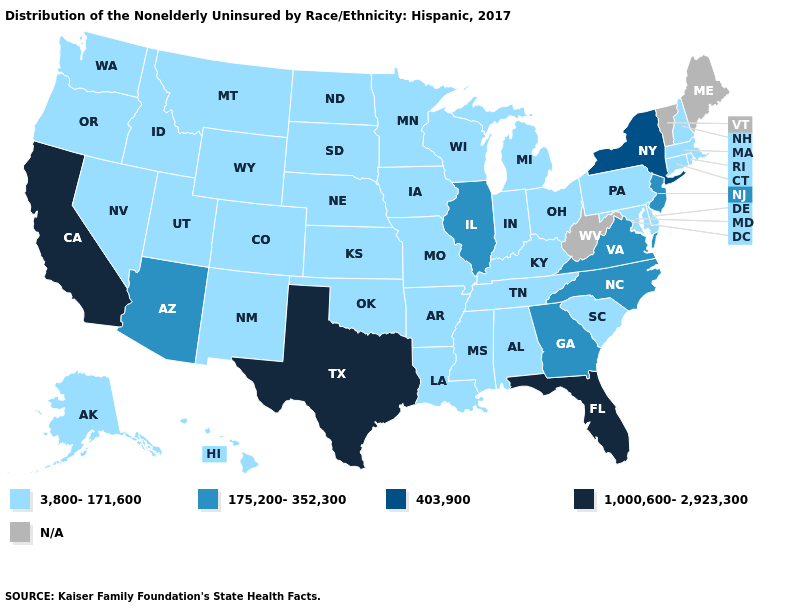What is the lowest value in the USA?
Answer briefly. 3,800-171,600. What is the value of Pennsylvania?
Keep it brief. 3,800-171,600. What is the lowest value in the MidWest?
Write a very short answer. 3,800-171,600. Among the states that border Pennsylvania , which have the highest value?
Keep it brief. New York. Among the states that border Indiana , which have the highest value?
Write a very short answer. Illinois. Which states have the highest value in the USA?
Concise answer only. California, Florida, Texas. Among the states that border Louisiana , which have the lowest value?
Be succinct. Arkansas, Mississippi. Does New Jersey have the highest value in the Northeast?
Give a very brief answer. No. Name the states that have a value in the range 3,800-171,600?
Short answer required. Alabama, Alaska, Arkansas, Colorado, Connecticut, Delaware, Hawaii, Idaho, Indiana, Iowa, Kansas, Kentucky, Louisiana, Maryland, Massachusetts, Michigan, Minnesota, Mississippi, Missouri, Montana, Nebraska, Nevada, New Hampshire, New Mexico, North Dakota, Ohio, Oklahoma, Oregon, Pennsylvania, Rhode Island, South Carolina, South Dakota, Tennessee, Utah, Washington, Wisconsin, Wyoming. Which states hav the highest value in the South?
Keep it brief. Florida, Texas. Which states have the lowest value in the USA?
Be succinct. Alabama, Alaska, Arkansas, Colorado, Connecticut, Delaware, Hawaii, Idaho, Indiana, Iowa, Kansas, Kentucky, Louisiana, Maryland, Massachusetts, Michigan, Minnesota, Mississippi, Missouri, Montana, Nebraska, Nevada, New Hampshire, New Mexico, North Dakota, Ohio, Oklahoma, Oregon, Pennsylvania, Rhode Island, South Carolina, South Dakota, Tennessee, Utah, Washington, Wisconsin, Wyoming. What is the value of New Hampshire?
Short answer required. 3,800-171,600. What is the value of Ohio?
Give a very brief answer. 3,800-171,600. 